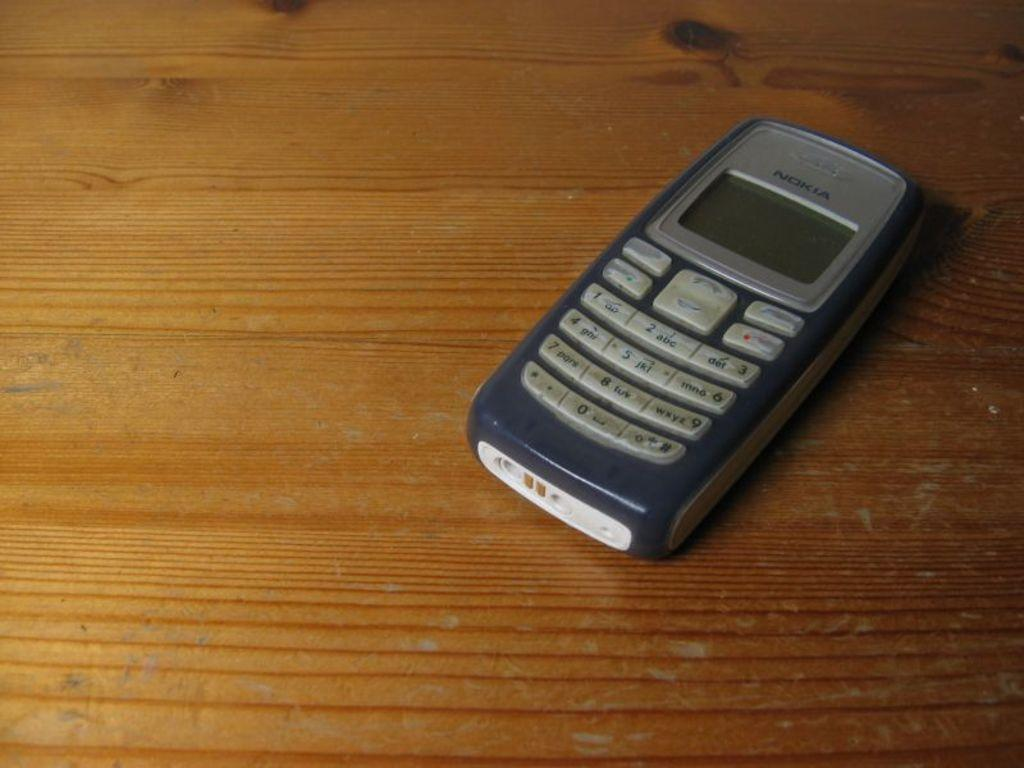<image>
Create a compact narrative representing the image presented. An older grey Nokia cell phone laying on a table. 